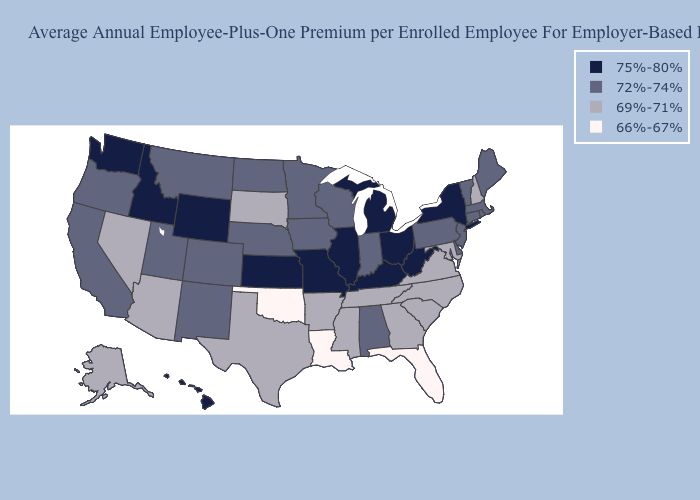Does Nebraska have the highest value in the USA?
Short answer required. No. How many symbols are there in the legend?
Keep it brief. 4. What is the highest value in the MidWest ?
Concise answer only. 75%-80%. Name the states that have a value in the range 75%-80%?
Quick response, please. Hawaii, Idaho, Illinois, Kansas, Kentucky, Michigan, Missouri, New York, Ohio, Washington, West Virginia, Wyoming. Which states have the lowest value in the USA?
Answer briefly. Florida, Louisiana, Oklahoma. How many symbols are there in the legend?
Answer briefly. 4. What is the highest value in the South ?
Quick response, please. 75%-80%. Name the states that have a value in the range 69%-71%?
Write a very short answer. Alaska, Arizona, Arkansas, Georgia, Maryland, Mississippi, Nevada, New Hampshire, North Carolina, South Carolina, South Dakota, Tennessee, Texas, Virginia. What is the value of North Dakota?
Write a very short answer. 72%-74%. Does Pennsylvania have the lowest value in the Northeast?
Quick response, please. No. Among the states that border Oregon , which have the highest value?
Concise answer only. Idaho, Washington. What is the highest value in the Northeast ?
Keep it brief. 75%-80%. Among the states that border Idaho , which have the highest value?
Give a very brief answer. Washington, Wyoming. What is the value of Wisconsin?
Short answer required. 72%-74%. Does Wisconsin have the highest value in the MidWest?
Keep it brief. No. 